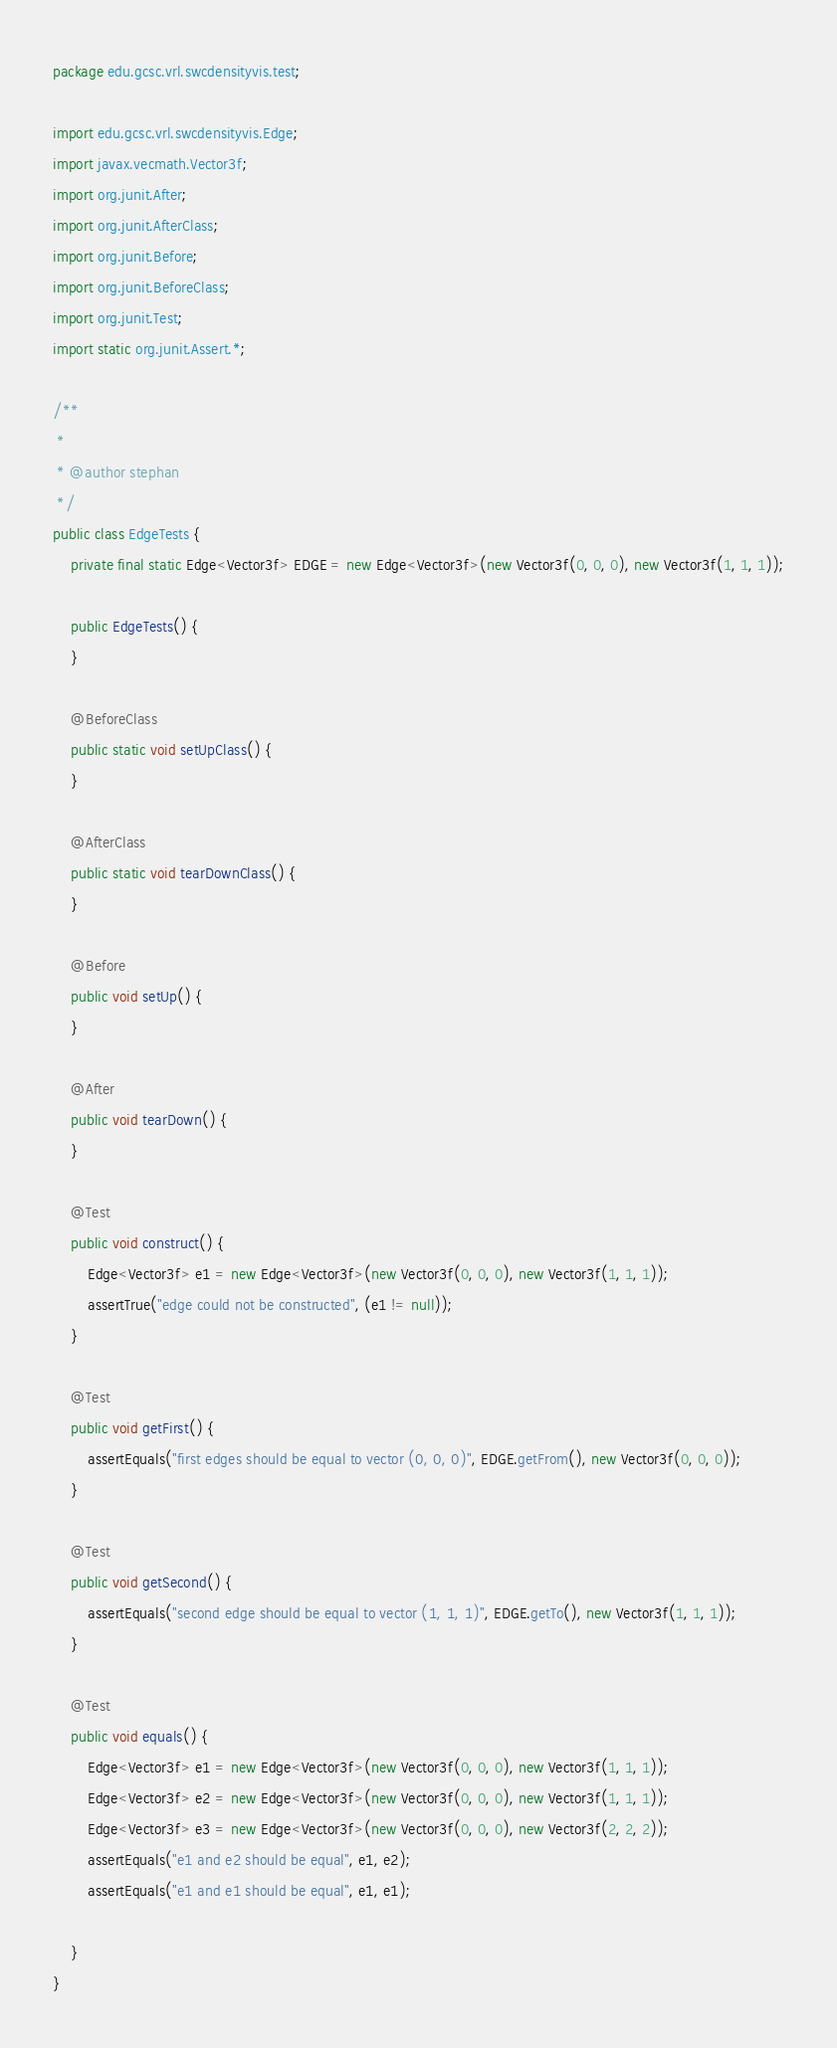<code> <loc_0><loc_0><loc_500><loc_500><_Java_>package edu.gcsc.vrl.swcdensityvis.test;

import edu.gcsc.vrl.swcdensityvis.Edge;
import javax.vecmath.Vector3f;
import org.junit.After;
import org.junit.AfterClass;
import org.junit.Before;
import org.junit.BeforeClass;
import org.junit.Test;
import static org.junit.Assert.*;

/**
 *
 * @author stephan
 */
public class EdgeTests {
	private final static Edge<Vector3f> EDGE = new Edge<Vector3f>(new Vector3f(0, 0, 0), new Vector3f(1, 1, 1));
	
	public EdgeTests() {
	}
	
	@BeforeClass
	public static void setUpClass() {
	}
	
	@AfterClass
	public static void tearDownClass() {
	}
	
	@Before
	public void setUp() {
	}
	
	@After
	public void tearDown() {
	}
	
	@Test
	public void construct() {
		Edge<Vector3f> e1 = new Edge<Vector3f>(new Vector3f(0, 0, 0), new Vector3f(1, 1, 1));
		assertTrue("edge could not be constructed", (e1 != null));
	}
	
	@Test
	public void getFirst() {
		assertEquals("first edges should be equal to vector (0, 0, 0)", EDGE.getFrom(), new Vector3f(0, 0, 0));
	}
	
	@Test
	public void getSecond() {
		assertEquals("second edge should be equal to vector (1, 1, 1)", EDGE.getTo(), new Vector3f(1, 1, 1));
	}

	@Test
	public void equals() {
		Edge<Vector3f> e1 = new Edge<Vector3f>(new Vector3f(0, 0, 0), new Vector3f(1, 1, 1));
		Edge<Vector3f> e2 = new Edge<Vector3f>(new Vector3f(0, 0, 0), new Vector3f(1, 1, 1));
		Edge<Vector3f> e3 = new Edge<Vector3f>(new Vector3f(0, 0, 0), new Vector3f(2, 2, 2));
		assertEquals("e1 and e2 should be equal", e1, e2);
		assertEquals("e1 and e1 should be equal", e1, e1);
		
	}
}
</code> 